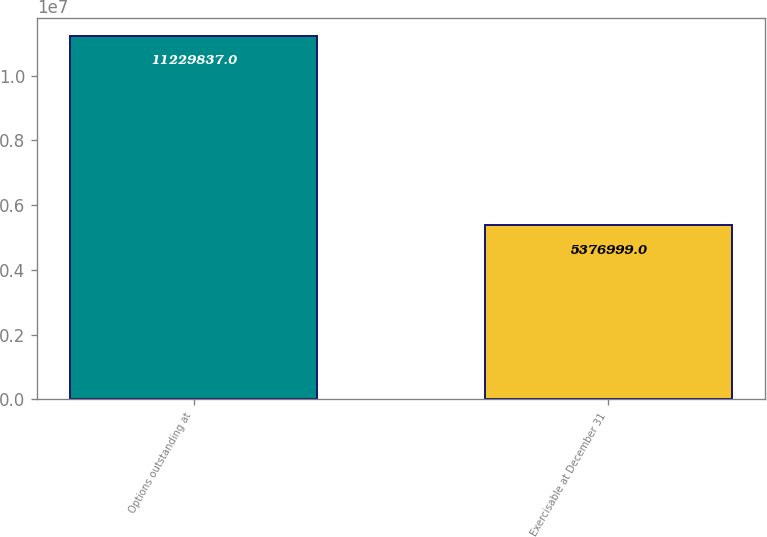Convert chart to OTSL. <chart><loc_0><loc_0><loc_500><loc_500><bar_chart><fcel>Options outstanding at<fcel>Exercisable at December 31<nl><fcel>1.12298e+07<fcel>5.377e+06<nl></chart> 